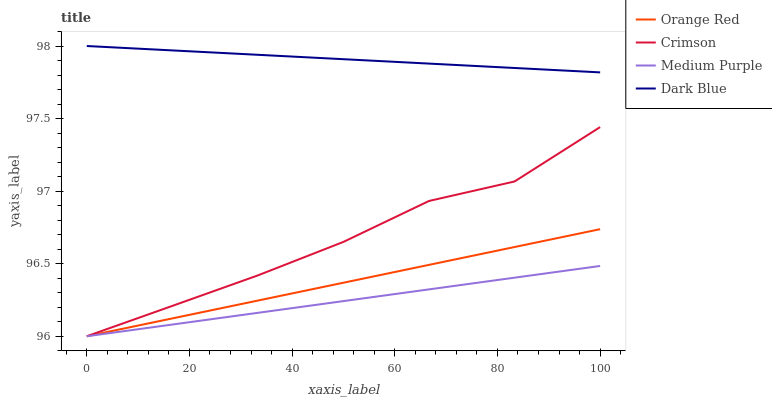Does Orange Red have the minimum area under the curve?
Answer yes or no. No. Does Orange Red have the maximum area under the curve?
Answer yes or no. No. Is Medium Purple the smoothest?
Answer yes or no. No. Is Medium Purple the roughest?
Answer yes or no. No. Does Dark Blue have the lowest value?
Answer yes or no. No. Does Orange Red have the highest value?
Answer yes or no. No. Is Medium Purple less than Dark Blue?
Answer yes or no. Yes. Is Dark Blue greater than Crimson?
Answer yes or no. Yes. Does Medium Purple intersect Dark Blue?
Answer yes or no. No. 